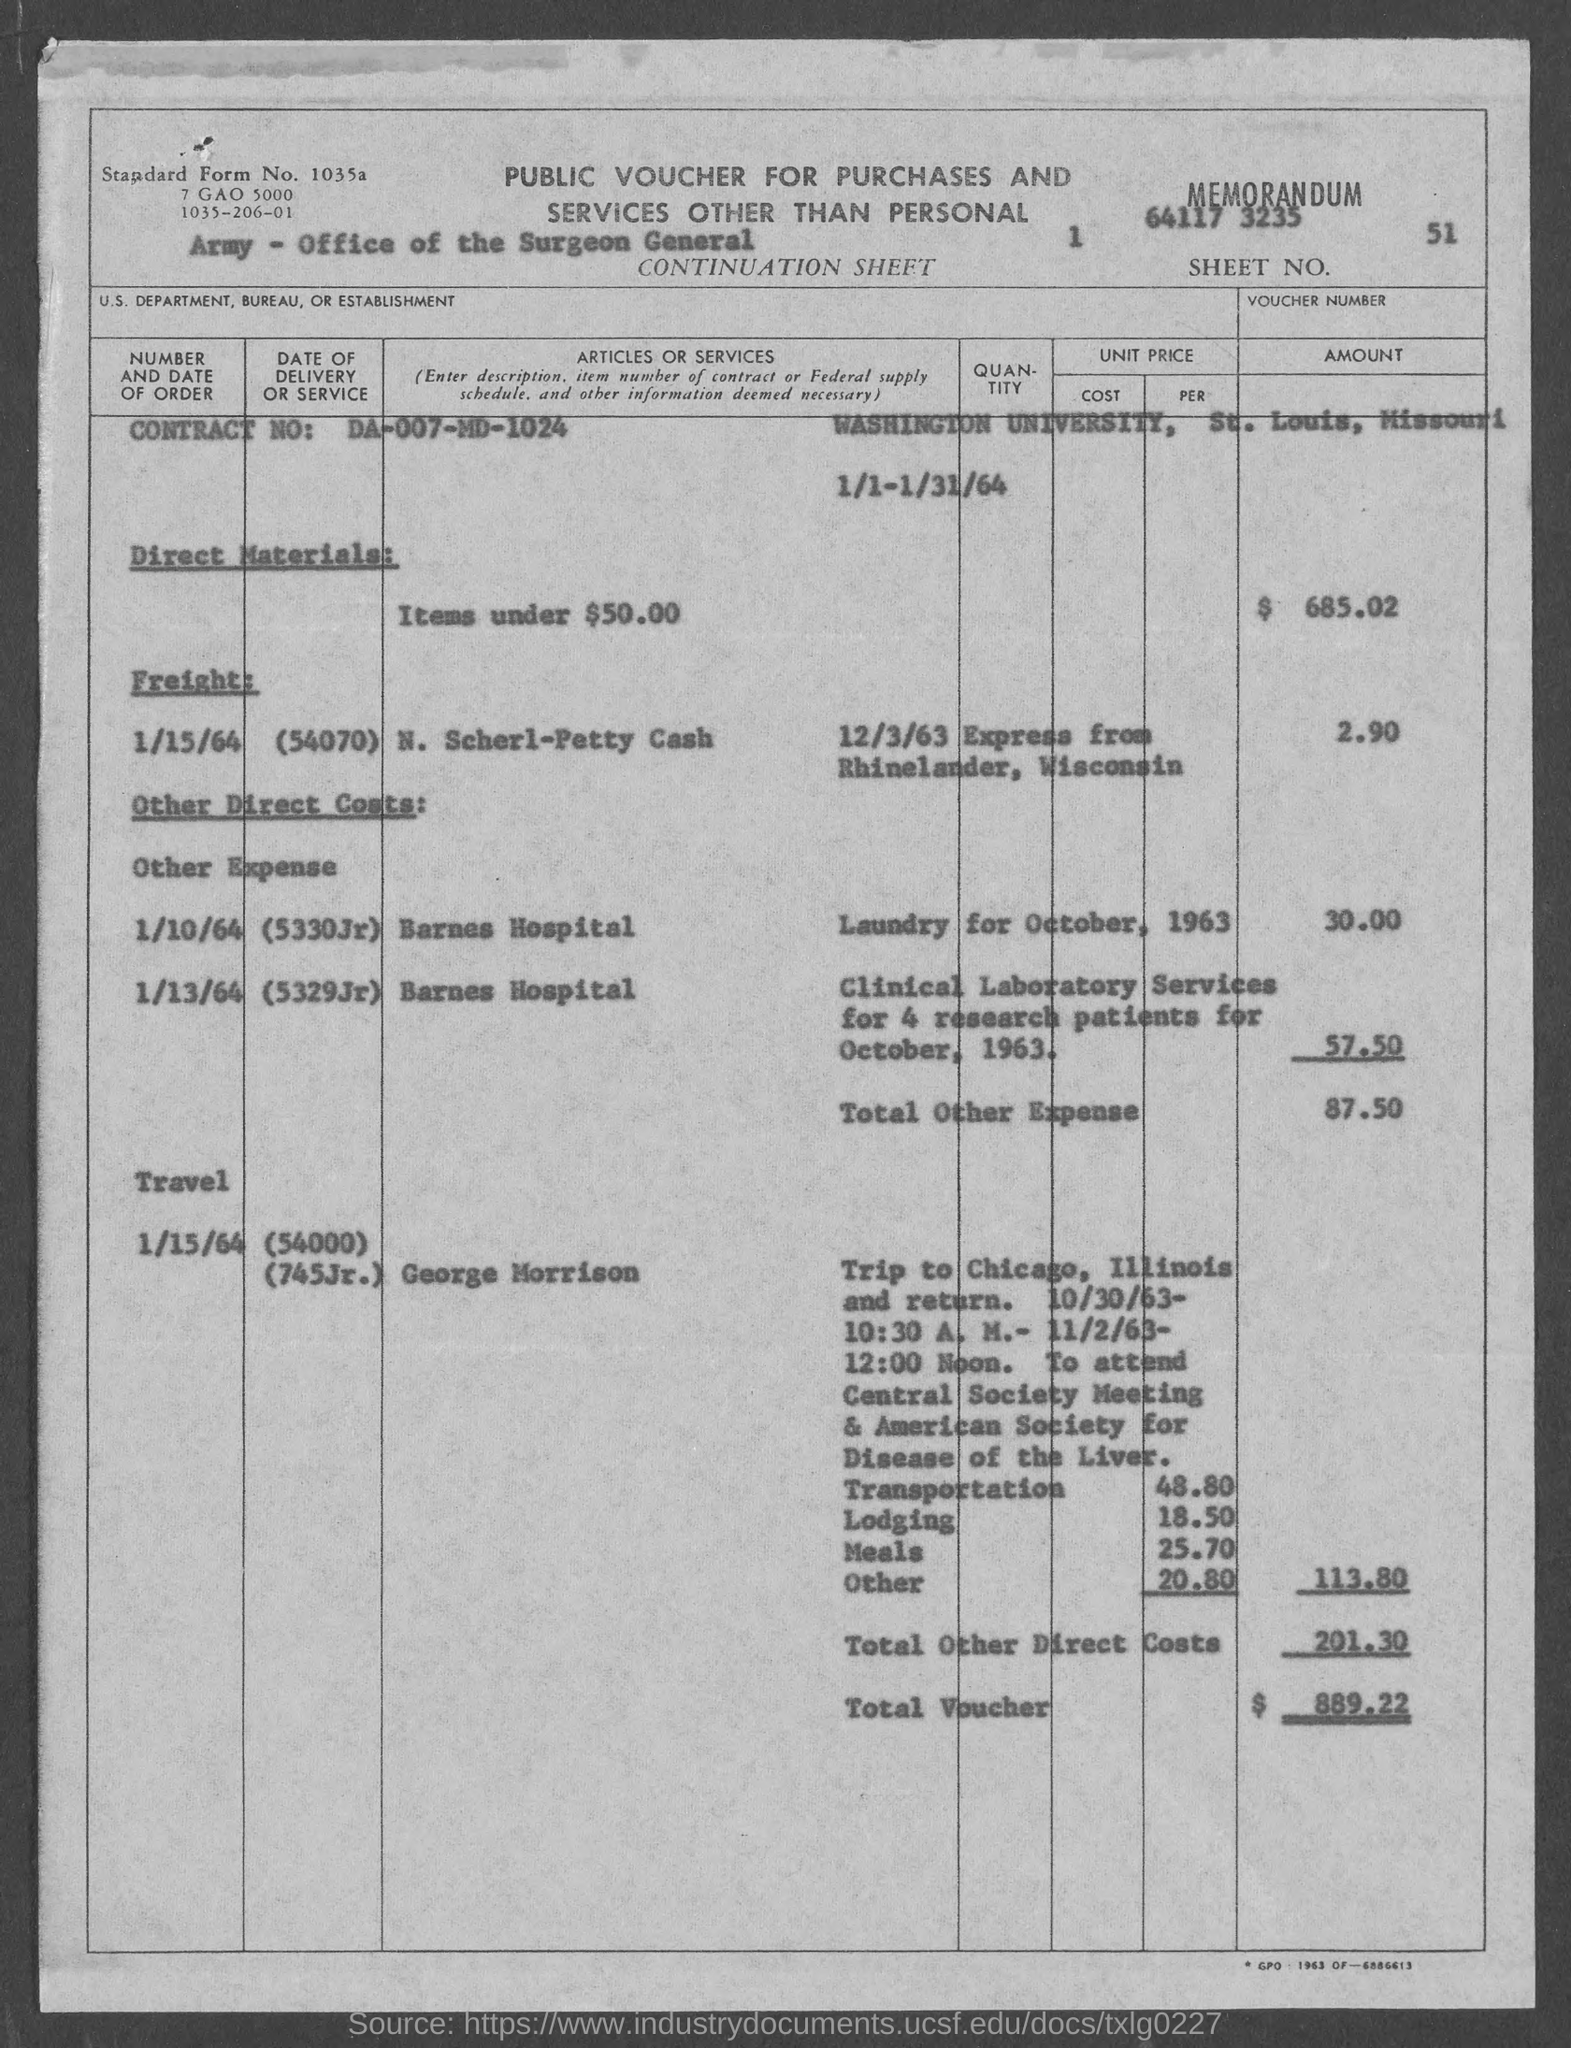Highlight a few significant elements in this photo. The date mentioned under the subheading "Freight" is 1/15/64. In October, 1963, four research patients were offered clinical laboratory services. The location of Washington University is St. Louis. The "contract no." mentioned is DA-007-MD-1024.. The value listed against "Lodging" is 18.50. 